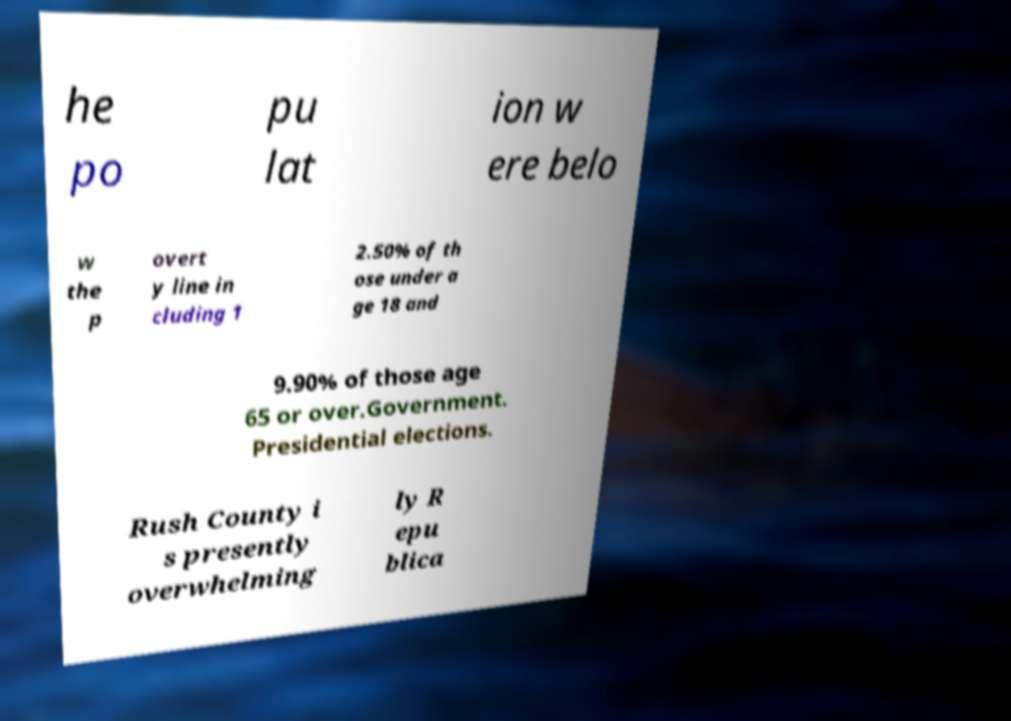Could you extract and type out the text from this image? he po pu lat ion w ere belo w the p overt y line in cluding 1 2.50% of th ose under a ge 18 and 9.90% of those age 65 or over.Government. Presidential elections. Rush County i s presently overwhelming ly R epu blica 